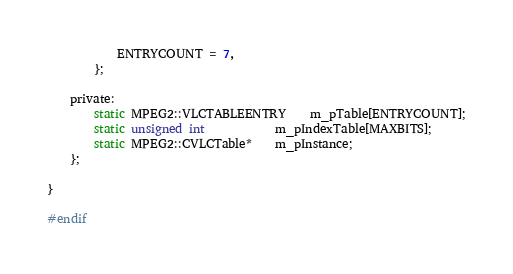<code> <loc_0><loc_0><loc_500><loc_500><_C_>			ENTRYCOUNT = 7,
		};

	private:
		static MPEG2::VLCTABLEENTRY	m_pTable[ENTRYCOUNT];
		static unsigned int			m_pIndexTable[MAXBITS];
		static MPEG2::CVLCTable*	m_pInstance;
	};

}

#endif
</code> 